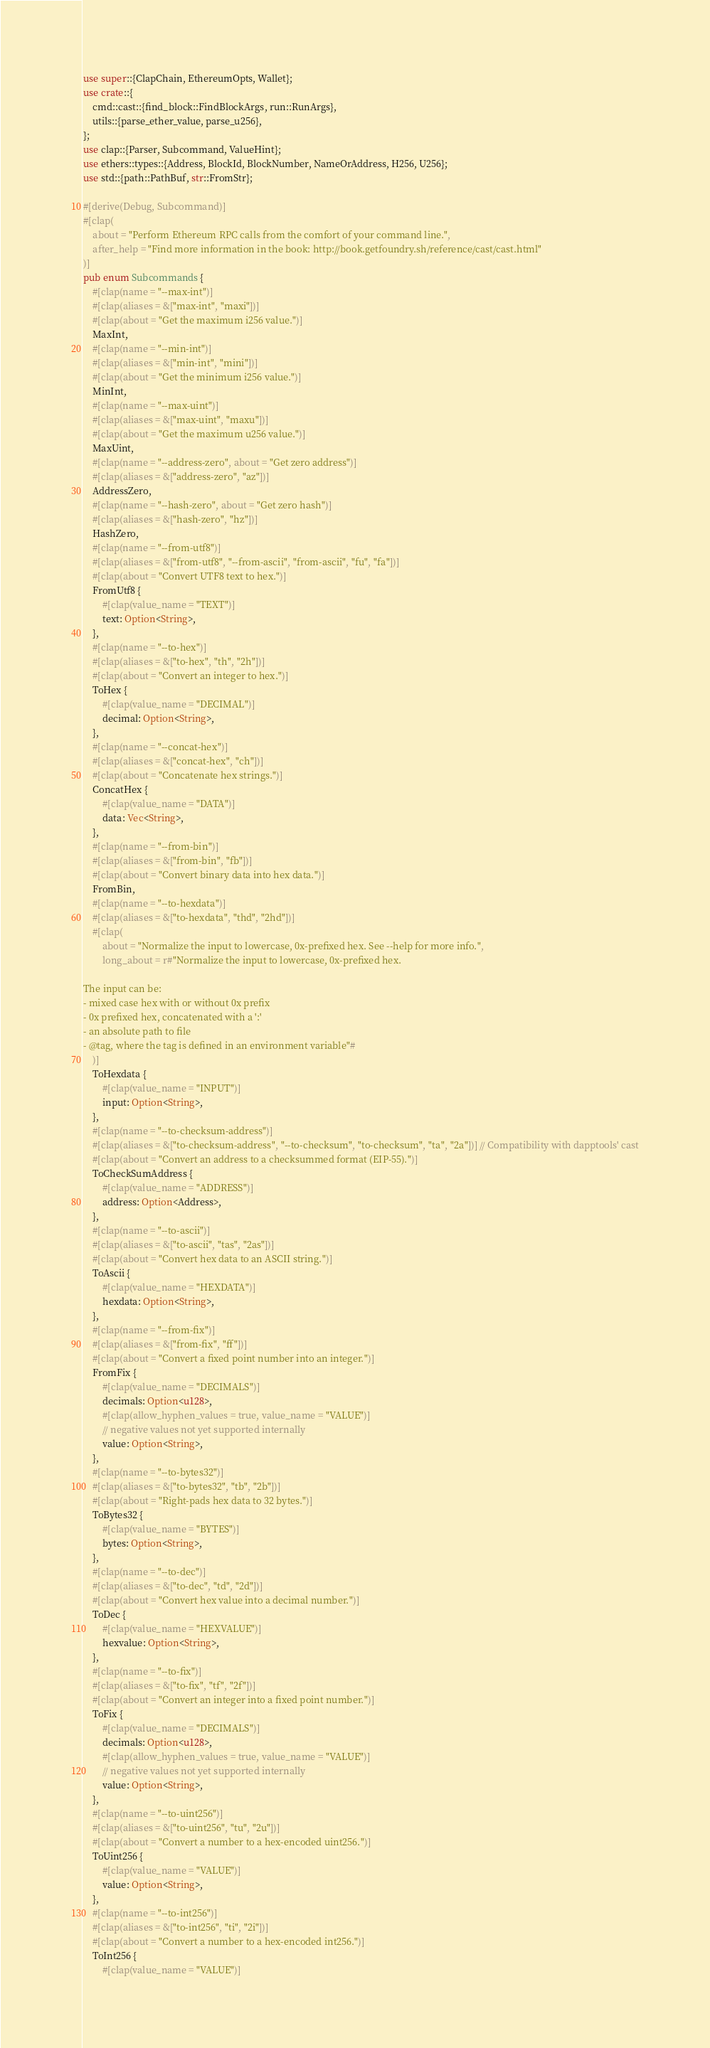<code> <loc_0><loc_0><loc_500><loc_500><_Rust_>use super::{ClapChain, EthereumOpts, Wallet};
use crate::{
    cmd::cast::{find_block::FindBlockArgs, run::RunArgs},
    utils::{parse_ether_value, parse_u256},
};
use clap::{Parser, Subcommand, ValueHint};
use ethers::types::{Address, BlockId, BlockNumber, NameOrAddress, H256, U256};
use std::{path::PathBuf, str::FromStr};

#[derive(Debug, Subcommand)]
#[clap(
    about = "Perform Ethereum RPC calls from the comfort of your command line.",
    after_help = "Find more information in the book: http://book.getfoundry.sh/reference/cast/cast.html"
)]
pub enum Subcommands {
    #[clap(name = "--max-int")]
    #[clap(aliases = &["max-int", "maxi"])]
    #[clap(about = "Get the maximum i256 value.")]
    MaxInt,
    #[clap(name = "--min-int")]
    #[clap(aliases = &["min-int", "mini"])]
    #[clap(about = "Get the minimum i256 value.")]
    MinInt,
    #[clap(name = "--max-uint")]
    #[clap(aliases = &["max-uint", "maxu"])]
    #[clap(about = "Get the maximum u256 value.")]
    MaxUint,
    #[clap(name = "--address-zero", about = "Get zero address")]
    #[clap(aliases = &["address-zero", "az"])]
    AddressZero,
    #[clap(name = "--hash-zero", about = "Get zero hash")]
    #[clap(aliases = &["hash-zero", "hz"])]
    HashZero,
    #[clap(name = "--from-utf8")]
    #[clap(aliases = &["from-utf8", "--from-ascii", "from-ascii", "fu", "fa"])]
    #[clap(about = "Convert UTF8 text to hex.")]
    FromUtf8 {
        #[clap(value_name = "TEXT")]
        text: Option<String>,
    },
    #[clap(name = "--to-hex")]
    #[clap(aliases = &["to-hex", "th", "2h"])]
    #[clap(about = "Convert an integer to hex.")]
    ToHex {
        #[clap(value_name = "DECIMAL")]
        decimal: Option<String>,
    },
    #[clap(name = "--concat-hex")]
    #[clap(aliases = &["concat-hex", "ch"])]
    #[clap(about = "Concatenate hex strings.")]
    ConcatHex {
        #[clap(value_name = "DATA")]
        data: Vec<String>,
    },
    #[clap(name = "--from-bin")]
    #[clap(aliases = &["from-bin", "fb"])]
    #[clap(about = "Convert binary data into hex data.")]
    FromBin,
    #[clap(name = "--to-hexdata")]
    #[clap(aliases = &["to-hexdata", "thd", "2hd"])]
    #[clap(
        about = "Normalize the input to lowercase, 0x-prefixed hex. See --help for more info.",
        long_about = r#"Normalize the input to lowercase, 0x-prefixed hex.

The input can be:
- mixed case hex with or without 0x prefix
- 0x prefixed hex, concatenated with a ':'
- an absolute path to file
- @tag, where the tag is defined in an environment variable"#
    )]
    ToHexdata {
        #[clap(value_name = "INPUT")]
        input: Option<String>,
    },
    #[clap(name = "--to-checksum-address")]
    #[clap(aliases = &["to-checksum-address", "--to-checksum", "to-checksum", "ta", "2a"])] // Compatibility with dapptools' cast
    #[clap(about = "Convert an address to a checksummed format (EIP-55).")]
    ToCheckSumAddress {
        #[clap(value_name = "ADDRESS")]
        address: Option<Address>,
    },
    #[clap(name = "--to-ascii")]
    #[clap(aliases = &["to-ascii", "tas", "2as"])]
    #[clap(about = "Convert hex data to an ASCII string.")]
    ToAscii {
        #[clap(value_name = "HEXDATA")]
        hexdata: Option<String>,
    },
    #[clap(name = "--from-fix")]
    #[clap(aliases = &["from-fix", "ff"])]
    #[clap(about = "Convert a fixed point number into an integer.")]
    FromFix {
        #[clap(value_name = "DECIMALS")]
        decimals: Option<u128>,
        #[clap(allow_hyphen_values = true, value_name = "VALUE")]
        // negative values not yet supported internally
        value: Option<String>,
    },
    #[clap(name = "--to-bytes32")]
    #[clap(aliases = &["to-bytes32", "tb", "2b"])]
    #[clap(about = "Right-pads hex data to 32 bytes.")]
    ToBytes32 {
        #[clap(value_name = "BYTES")]
        bytes: Option<String>,
    },
    #[clap(name = "--to-dec")]
    #[clap(aliases = &["to-dec", "td", "2d"])]
    #[clap(about = "Convert hex value into a decimal number.")]
    ToDec {
        #[clap(value_name = "HEXVALUE")]
        hexvalue: Option<String>,
    },
    #[clap(name = "--to-fix")]
    #[clap(aliases = &["to-fix", "tf", "2f"])]
    #[clap(about = "Convert an integer into a fixed point number.")]
    ToFix {
        #[clap(value_name = "DECIMALS")]
        decimals: Option<u128>,
        #[clap(allow_hyphen_values = true, value_name = "VALUE")]
        // negative values not yet supported internally
        value: Option<String>,
    },
    #[clap(name = "--to-uint256")]
    #[clap(aliases = &["to-uint256", "tu", "2u"])]
    #[clap(about = "Convert a number to a hex-encoded uint256.")]
    ToUint256 {
        #[clap(value_name = "VALUE")]
        value: Option<String>,
    },
    #[clap(name = "--to-int256")]
    #[clap(aliases = &["to-int256", "ti", "2i"])]
    #[clap(about = "Convert a number to a hex-encoded int256.")]
    ToInt256 {
        #[clap(value_name = "VALUE")]</code> 